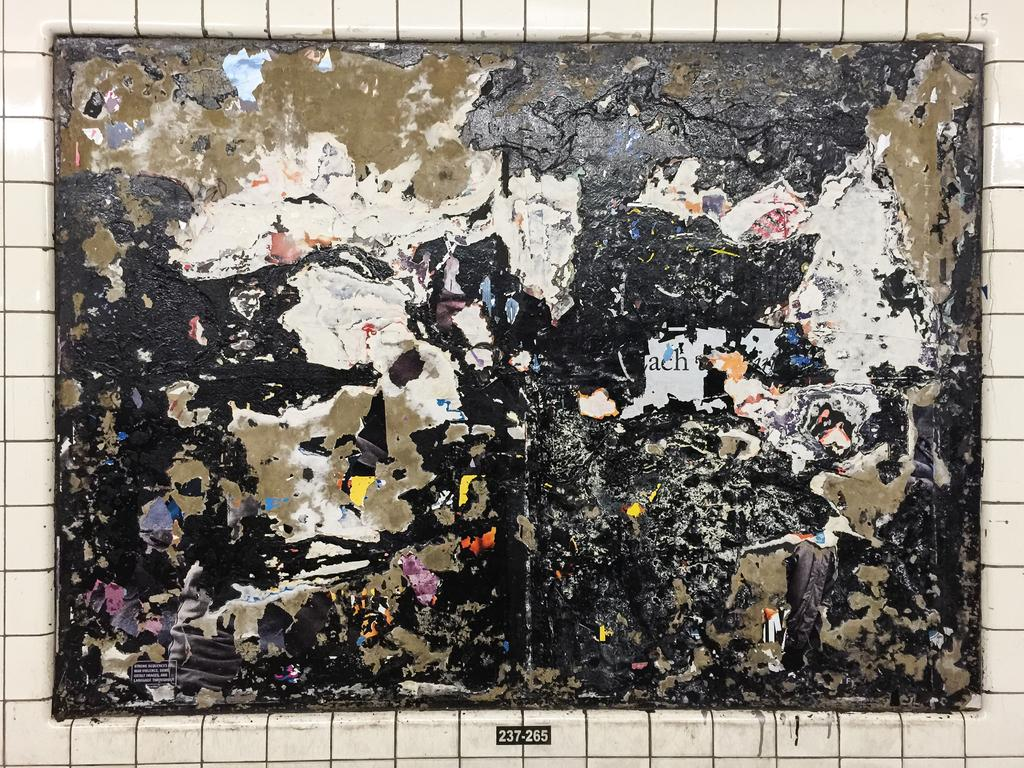<image>
Present a compact description of the photo's key features. The code written underneath this mess is 237-265. 